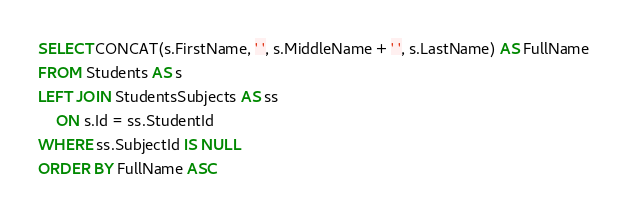Convert code to text. <code><loc_0><loc_0><loc_500><loc_500><_SQL_>SELECT CONCAT(s.FirstName, ' ', s.MiddleName + ' ', s.LastName) AS FullName
FROM Students AS s
LEFT JOIN StudentsSubjects AS ss
	ON s.Id = ss.StudentId
WHERE ss.SubjectId IS NULL
ORDER BY FullName ASC</code> 